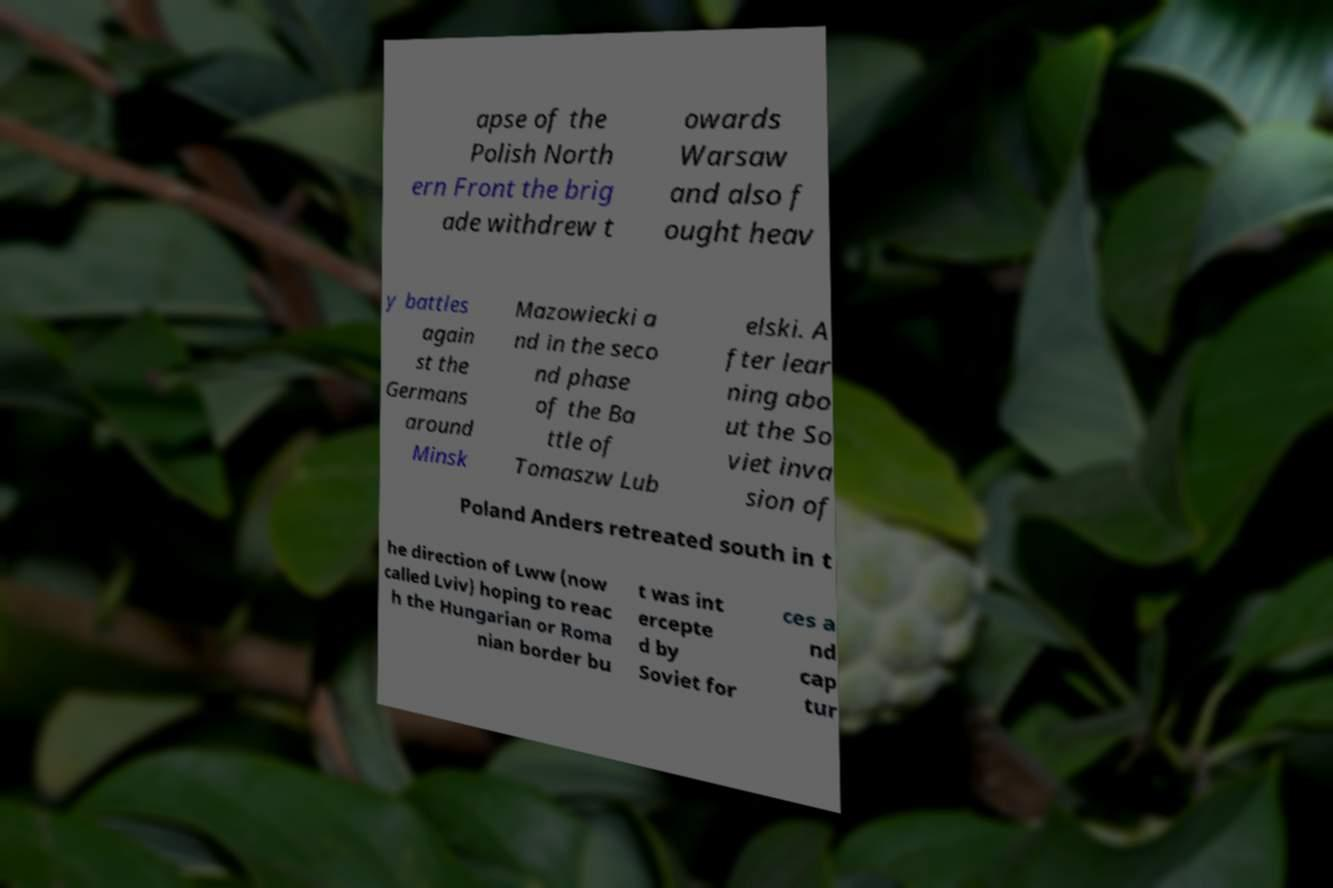Can you accurately transcribe the text from the provided image for me? apse of the Polish North ern Front the brig ade withdrew t owards Warsaw and also f ought heav y battles again st the Germans around Minsk Mazowiecki a nd in the seco nd phase of the Ba ttle of Tomaszw Lub elski. A fter lear ning abo ut the So viet inva sion of Poland Anders retreated south in t he direction of Lww (now called Lviv) hoping to reac h the Hungarian or Roma nian border bu t was int ercepte d by Soviet for ces a nd cap tur 